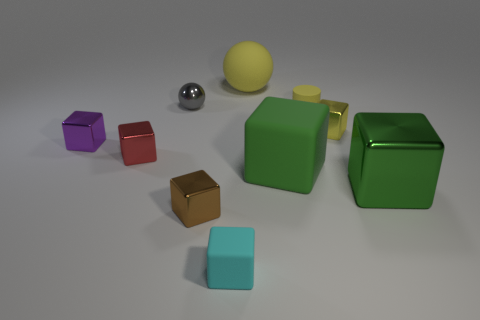Are there an equal number of small blocks that are left of the small red metal block and tiny brown things that are behind the yellow matte sphere?
Provide a short and direct response. No. There is a green cube on the left side of the big green metallic thing; what material is it?
Your answer should be compact. Rubber. How many things are either blocks that are to the left of the red metal cube or large green metallic things?
Your answer should be very brief. 2. What number of other things are there of the same shape as the big green metal thing?
Your answer should be compact. 6. Is the shape of the yellow thing that is behind the tiny ball the same as  the brown thing?
Your response must be concise. No. There is a brown shiny thing; are there any purple cubes in front of it?
Ensure brevity in your answer.  No. How many big objects are either red metallic things or spheres?
Provide a short and direct response. 1. Are the red object and the yellow cube made of the same material?
Offer a terse response. Yes. There is a block that is the same color as the large matte ball; what is its size?
Your answer should be very brief. Small. Are there any other metal cubes of the same color as the big metallic cube?
Provide a short and direct response. No. 